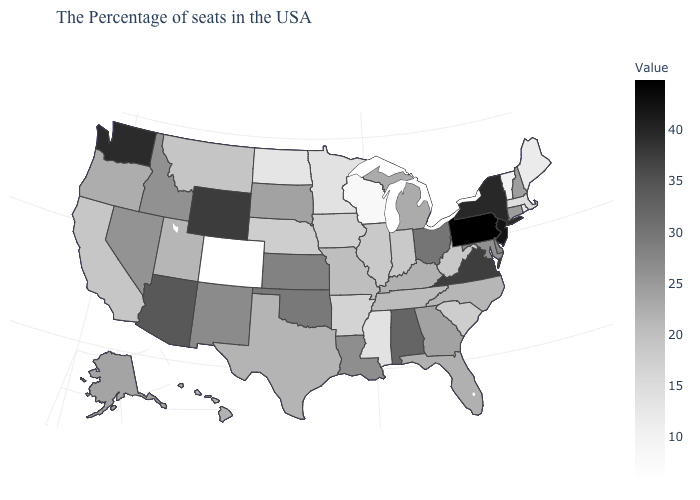Among the states that border New York , which have the lowest value?
Be succinct. Vermont. Among the states that border Delaware , does Maryland have the lowest value?
Give a very brief answer. Yes. Which states have the lowest value in the USA?
Be succinct. Colorado. Does Minnesota have a higher value than South Carolina?
Answer briefly. No. Which states have the highest value in the USA?
Keep it brief. Pennsylvania. Among the states that border Montana , which have the lowest value?
Answer briefly. North Dakota. Is the legend a continuous bar?
Write a very short answer. Yes. Which states hav the highest value in the Northeast?
Be succinct. Pennsylvania. Does Illinois have the lowest value in the USA?
Give a very brief answer. No. 